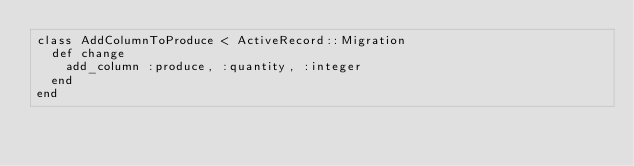<code> <loc_0><loc_0><loc_500><loc_500><_Ruby_>class AddColumnToProduce < ActiveRecord::Migration
  def change
    add_column :produce, :quantity, :integer
  end
end
</code> 